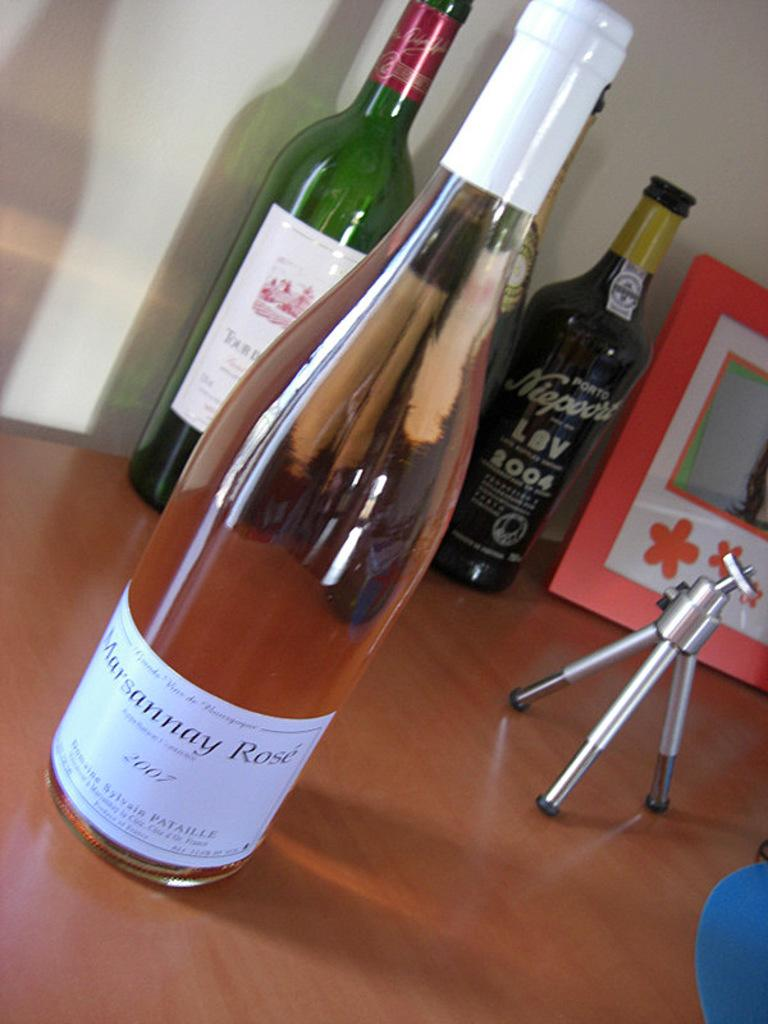<image>
Describe the image concisely. Several bottles of win sit on a table including a bottle of 2007 Marsannay Rose. 